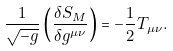Convert formula to latex. <formula><loc_0><loc_0><loc_500><loc_500>\frac { 1 } { \sqrt { - g } } \left ( \frac { \delta S _ { M } } { \delta g ^ { \mu \nu } } \right ) = - \frac { 1 } { 2 } T _ { \mu \nu } .</formula> 